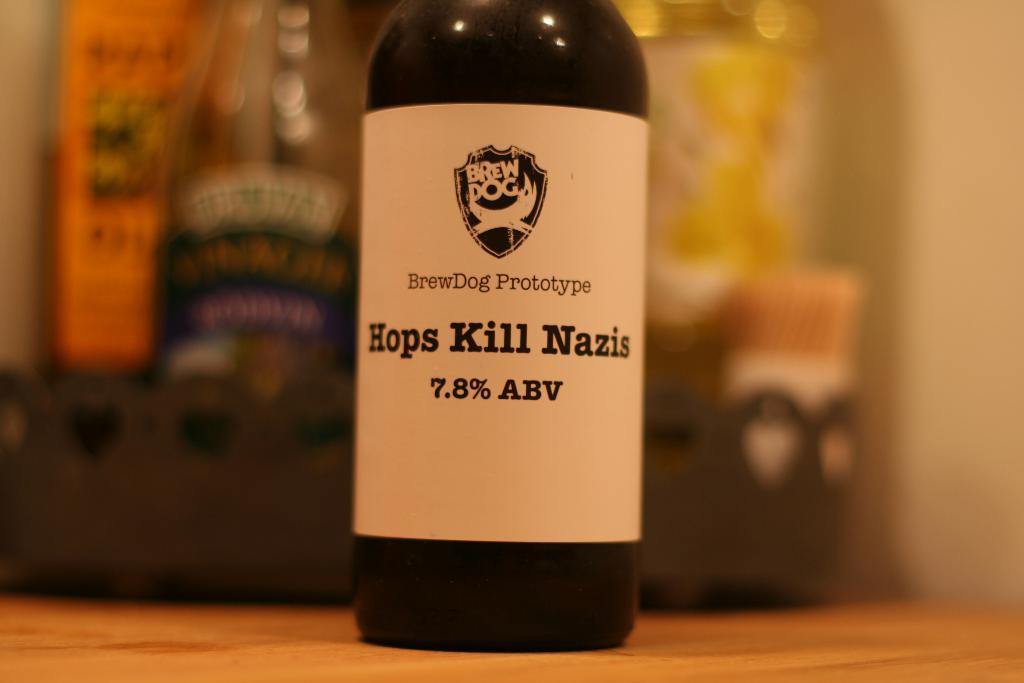What percentage of alcohol is in the bottle?
Give a very brief answer. 7.8%. 